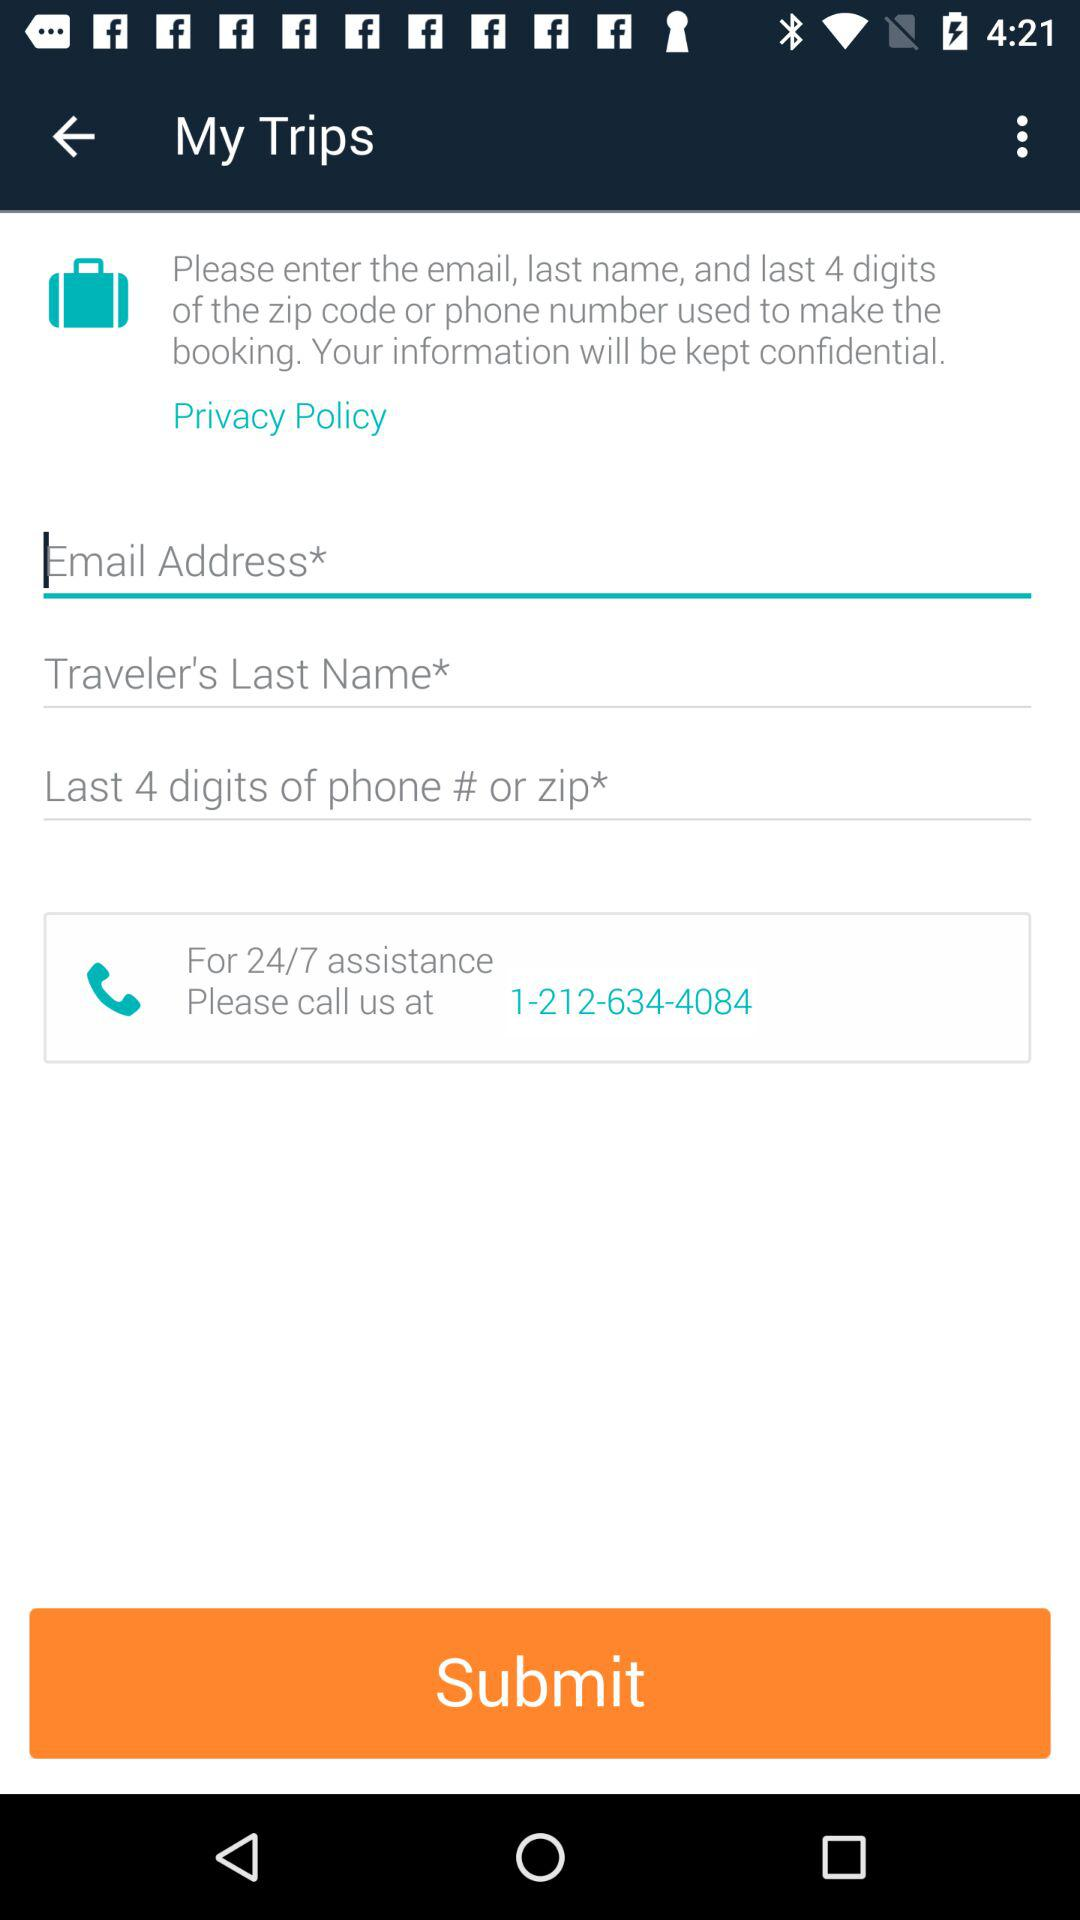What is the time duration for the assistance service? The time duration for the assistance service is 24/7. 